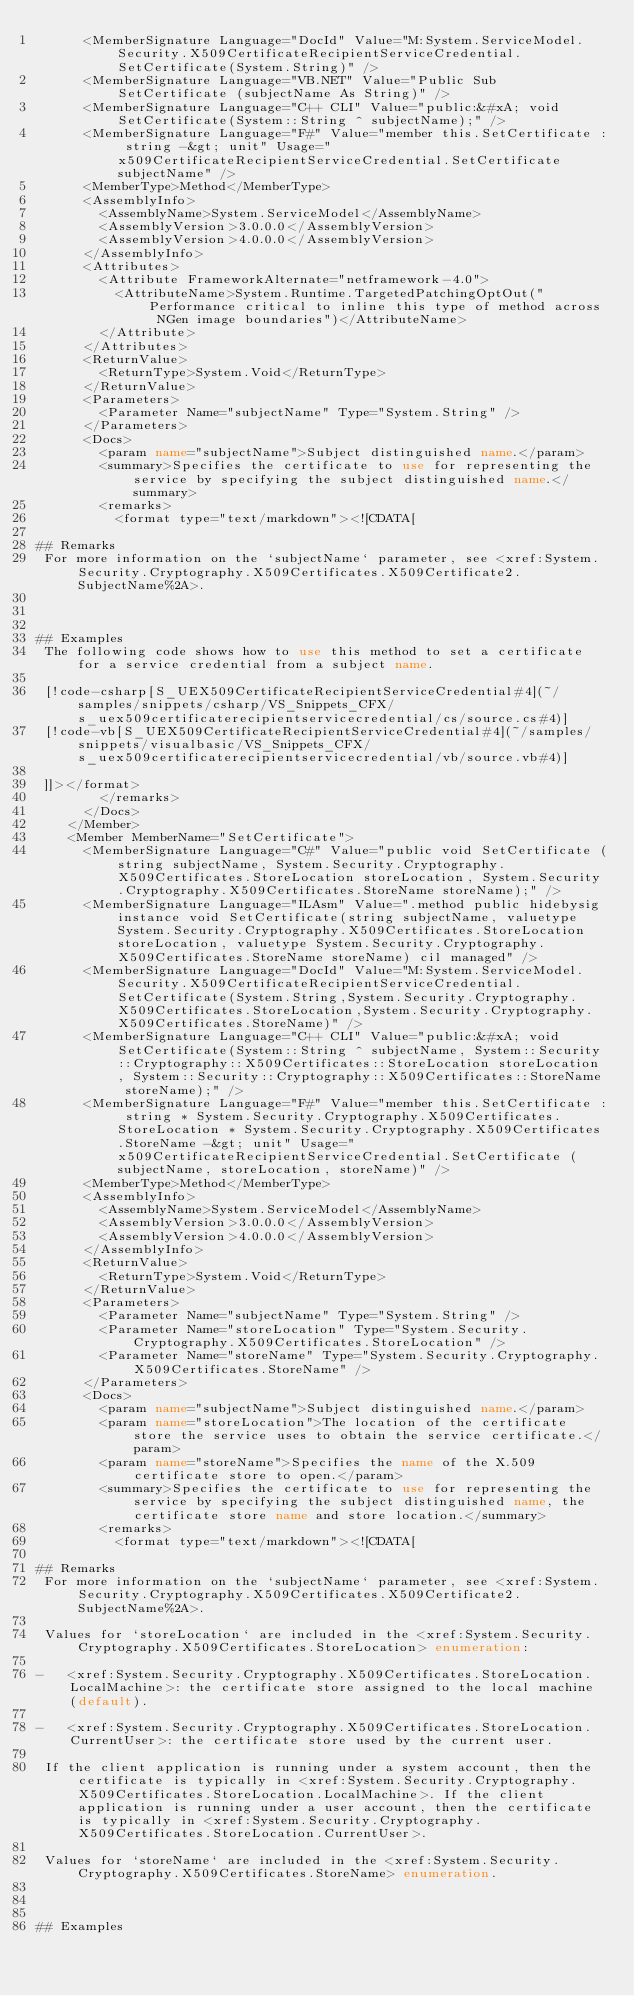Convert code to text. <code><loc_0><loc_0><loc_500><loc_500><_XML_>      <MemberSignature Language="DocId" Value="M:System.ServiceModel.Security.X509CertificateRecipientServiceCredential.SetCertificate(System.String)" />
      <MemberSignature Language="VB.NET" Value="Public Sub SetCertificate (subjectName As String)" />
      <MemberSignature Language="C++ CLI" Value="public:&#xA; void SetCertificate(System::String ^ subjectName);" />
      <MemberSignature Language="F#" Value="member this.SetCertificate : string -&gt; unit" Usage="x509CertificateRecipientServiceCredential.SetCertificate subjectName" />
      <MemberType>Method</MemberType>
      <AssemblyInfo>
        <AssemblyName>System.ServiceModel</AssemblyName>
        <AssemblyVersion>3.0.0.0</AssemblyVersion>
        <AssemblyVersion>4.0.0.0</AssemblyVersion>
      </AssemblyInfo>
      <Attributes>
        <Attribute FrameworkAlternate="netframework-4.0">
          <AttributeName>System.Runtime.TargetedPatchingOptOut("Performance critical to inline this type of method across NGen image boundaries")</AttributeName>
        </Attribute>
      </Attributes>
      <ReturnValue>
        <ReturnType>System.Void</ReturnType>
      </ReturnValue>
      <Parameters>
        <Parameter Name="subjectName" Type="System.String" />
      </Parameters>
      <Docs>
        <param name="subjectName">Subject distinguished name.</param>
        <summary>Specifies the certificate to use for representing the service by specifying the subject distinguished name.</summary>
        <remarks>
          <format type="text/markdown"><![CDATA[  
  
## Remarks  
 For more information on the `subjectName` parameter, see <xref:System.Security.Cryptography.X509Certificates.X509Certificate2.SubjectName%2A>.  
  
   
  
## Examples  
 The following code shows how to use this method to set a certificate for a service credential from a subject name.  
  
 [!code-csharp[S_UEX509CertificateRecipientServiceCredential#4](~/samples/snippets/csharp/VS_Snippets_CFX/s_uex509certificaterecipientservicecredential/cs/source.cs#4)]
 [!code-vb[S_UEX509CertificateRecipientServiceCredential#4](~/samples/snippets/visualbasic/VS_Snippets_CFX/s_uex509certificaterecipientservicecredential/vb/source.vb#4)]  
  
 ]]></format>
        </remarks>
      </Docs>
    </Member>
    <Member MemberName="SetCertificate">
      <MemberSignature Language="C#" Value="public void SetCertificate (string subjectName, System.Security.Cryptography.X509Certificates.StoreLocation storeLocation, System.Security.Cryptography.X509Certificates.StoreName storeName);" />
      <MemberSignature Language="ILAsm" Value=".method public hidebysig instance void SetCertificate(string subjectName, valuetype System.Security.Cryptography.X509Certificates.StoreLocation storeLocation, valuetype System.Security.Cryptography.X509Certificates.StoreName storeName) cil managed" />
      <MemberSignature Language="DocId" Value="M:System.ServiceModel.Security.X509CertificateRecipientServiceCredential.SetCertificate(System.String,System.Security.Cryptography.X509Certificates.StoreLocation,System.Security.Cryptography.X509Certificates.StoreName)" />
      <MemberSignature Language="C++ CLI" Value="public:&#xA; void SetCertificate(System::String ^ subjectName, System::Security::Cryptography::X509Certificates::StoreLocation storeLocation, System::Security::Cryptography::X509Certificates::StoreName storeName);" />
      <MemberSignature Language="F#" Value="member this.SetCertificate : string * System.Security.Cryptography.X509Certificates.StoreLocation * System.Security.Cryptography.X509Certificates.StoreName -&gt; unit" Usage="x509CertificateRecipientServiceCredential.SetCertificate (subjectName, storeLocation, storeName)" />
      <MemberType>Method</MemberType>
      <AssemblyInfo>
        <AssemblyName>System.ServiceModel</AssemblyName>
        <AssemblyVersion>3.0.0.0</AssemblyVersion>
        <AssemblyVersion>4.0.0.0</AssemblyVersion>
      </AssemblyInfo>
      <ReturnValue>
        <ReturnType>System.Void</ReturnType>
      </ReturnValue>
      <Parameters>
        <Parameter Name="subjectName" Type="System.String" />
        <Parameter Name="storeLocation" Type="System.Security.Cryptography.X509Certificates.StoreLocation" />
        <Parameter Name="storeName" Type="System.Security.Cryptography.X509Certificates.StoreName" />
      </Parameters>
      <Docs>
        <param name="subjectName">Subject distinguished name.</param>
        <param name="storeLocation">The location of the certificate store the service uses to obtain the service certificate.</param>
        <param name="storeName">Specifies the name of the X.509 certificate store to open.</param>
        <summary>Specifies the certificate to use for representing the service by specifying the subject distinguished name, the certificate store name and store location.</summary>
        <remarks>
          <format type="text/markdown"><![CDATA[  
  
## Remarks  
 For more information on the `subjectName` parameter, see <xref:System.Security.Cryptography.X509Certificates.X509Certificate2.SubjectName%2A>.  
  
 Values for `storeLocation` are included in the <xref:System.Security.Cryptography.X509Certificates.StoreLocation> enumeration:  
  
-   <xref:System.Security.Cryptography.X509Certificates.StoreLocation.LocalMachine>: the certificate store assigned to the local machine (default).  
  
-   <xref:System.Security.Cryptography.X509Certificates.StoreLocation.CurrentUser>: the certificate store used by the current user.  
  
 If the client application is running under a system account, then the certificate is typically in <xref:System.Security.Cryptography.X509Certificates.StoreLocation.LocalMachine>. If the client application is running under a user account, then the certificate is typically in <xref:System.Security.Cryptography.X509Certificates.StoreLocation.CurrentUser>.  
  
 Values for `storeName` are included in the <xref:System.Security.Cryptography.X509Certificates.StoreName> enumeration.  
  
   
  
## Examples  </code> 